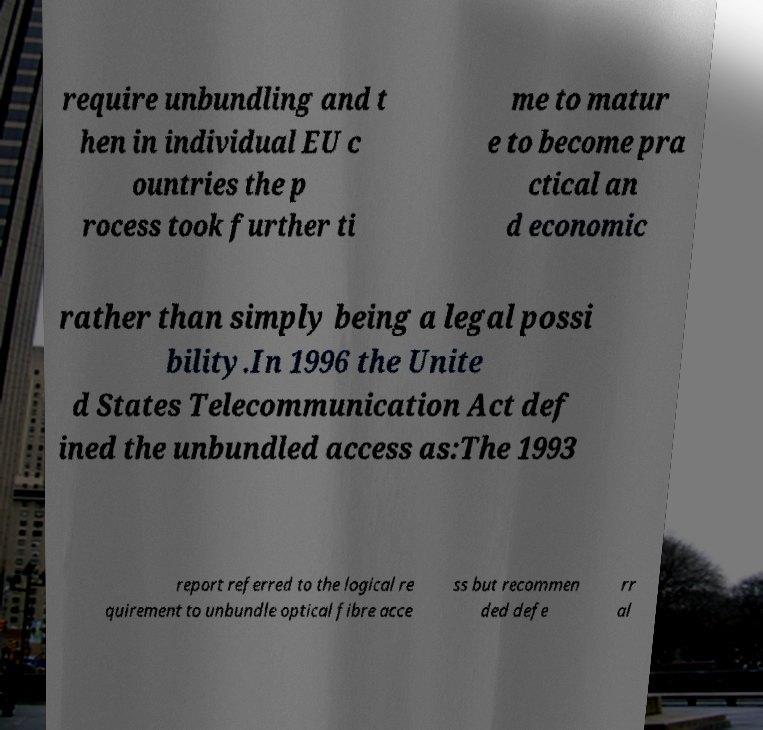What messages or text are displayed in this image? I need them in a readable, typed format. require unbundling and t hen in individual EU c ountries the p rocess took further ti me to matur e to become pra ctical an d economic rather than simply being a legal possi bility.In 1996 the Unite d States Telecommunication Act def ined the unbundled access as:The 1993 report referred to the logical re quirement to unbundle optical fibre acce ss but recommen ded defe rr al 